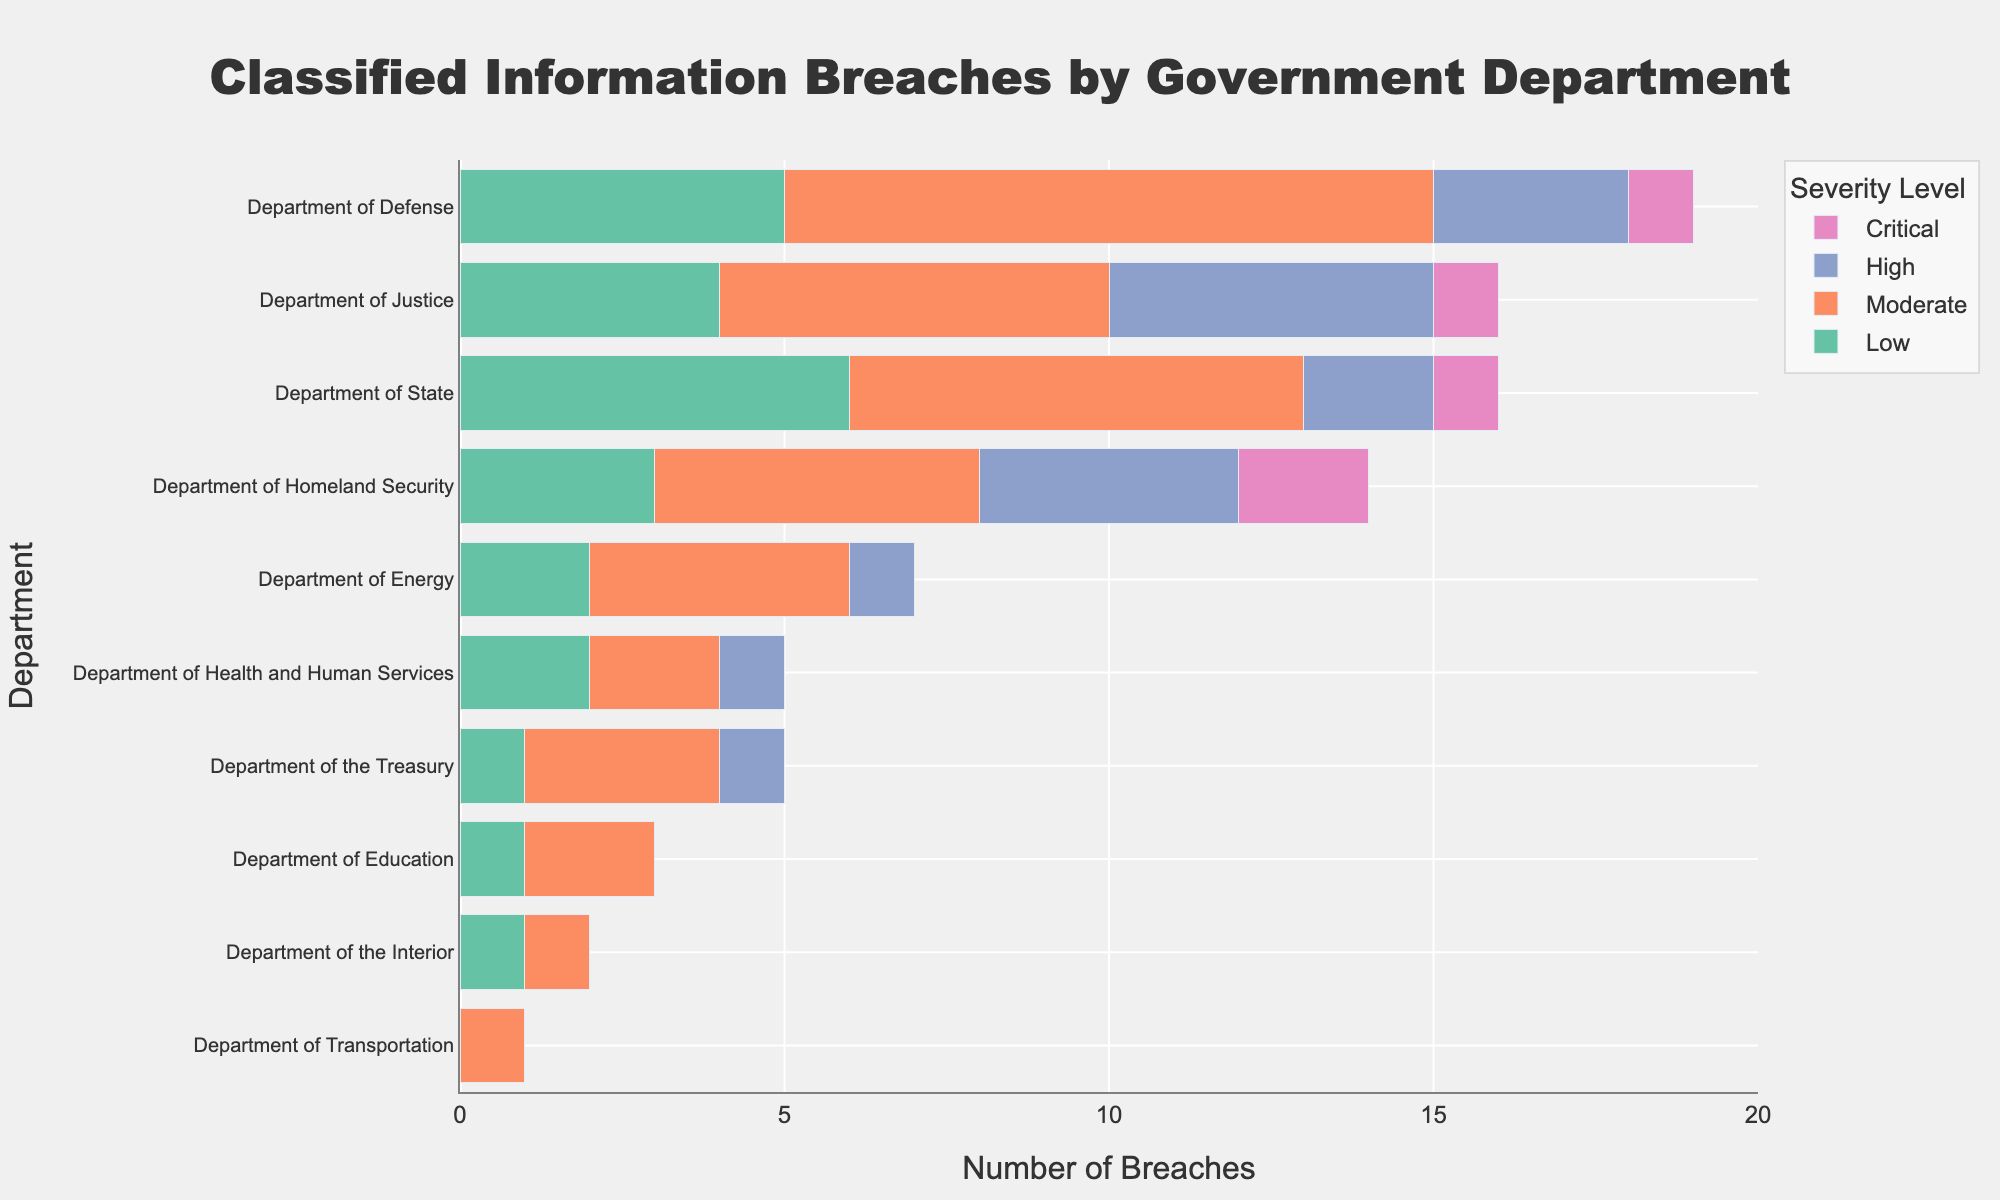Which department has the highest number of critical breaches? To determine this, look at the "Critical" category bars for each department and identify the longest bar. The Department of Homeland Security has the highest number of critical breaches with a count of 2.
Answer: The Department of Homeland Security What is the total number of breaches for the Department of State? Sum the number of breaches for each severity level within the Department of State. The total is 6 (Low) + 7 (Moderate) + 2 (High) + 1 (Critical) = 16.
Answer: 16 Which department has the lowest total number of breaches? Look at the sum of all breaches for each department and identify the smallest total. The Department of Transportation has the lowest total number of breaches, summing to just 1.
Answer: Department of Transportation How many more moderate breaches are there in the Department of Defense compared to the Department of Transportation? Calculate the difference in the number of moderate breaches between the two departments. The Department of Defense has 10 moderate breaches, whereas the Department of Transportation has 1. The difference is 10 - 1 = 9.
Answer: 9 What is the predominant severity level of breaches in the Department of Justice? Identify the longest bar within the Department of Justice for severity levels Low, Moderate, High, and Critical. The Moderate level, with 6 breaches, is the longest bar and thus predominant.
Answer: Moderate Compare the total number of high severity breaches between all departments. Which department has the highest? Summing up the high severity breaches for each department, the Department of Justice has the highest number, with 5 high severity breaches.
Answer: Department of Justice How many departments have zero critical breaches? Count the number of departments with a bar length of zero in the "Critical" category. These departments are the Department of Energy, Department of the Treasury, Department of Health and Human Services, Department of Education, Department of Transportation, and Department of the Interior, making a total of 6 departments.
Answer: 6 Is there any department that has an equal number of low and moderate breaches? Compare the low and moderate breach numbers for each department. The Department of Health and Human Services has 2 low and 2 moderate breaches, which are equal.
Answer: Department of Health and Human Services 